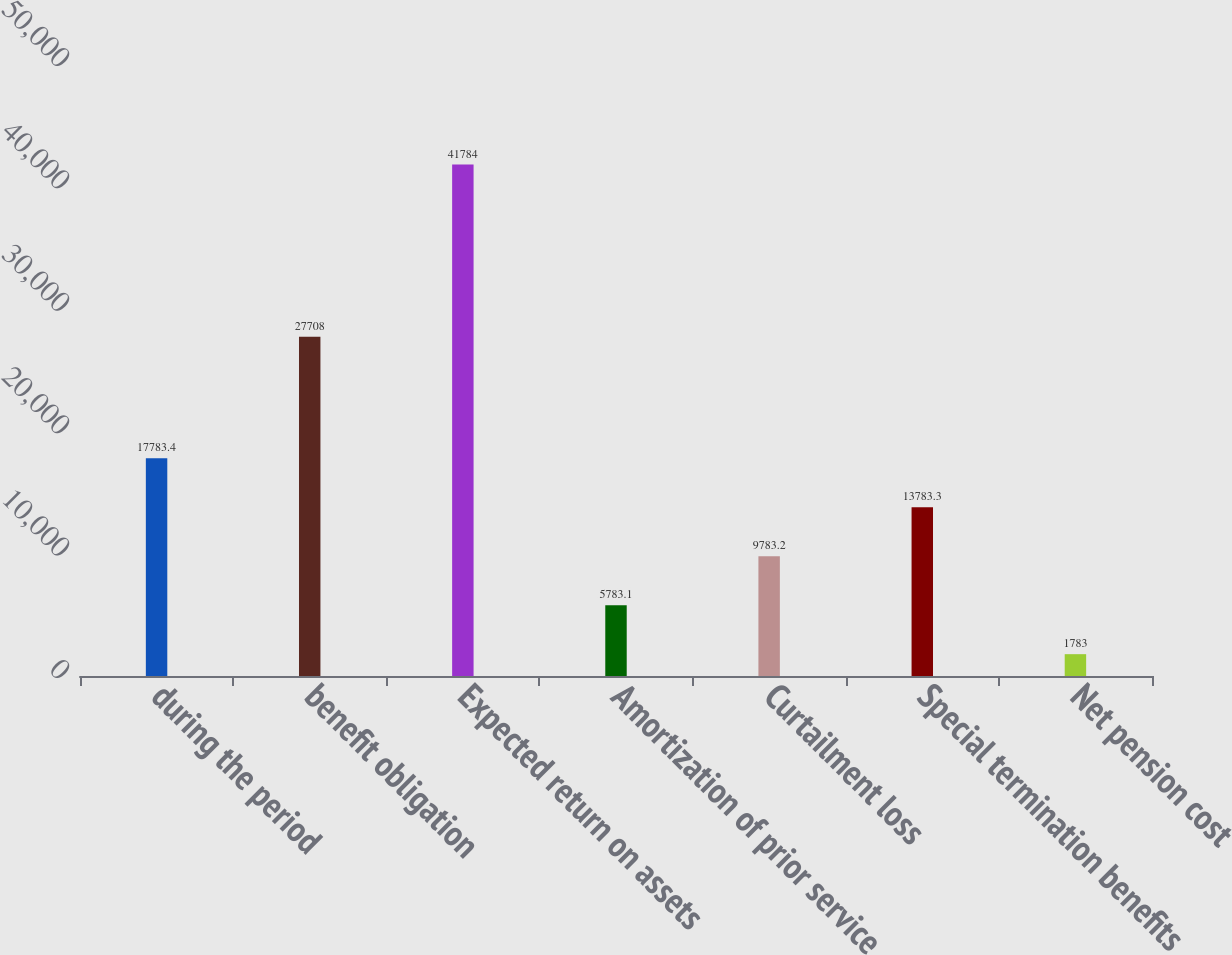Convert chart. <chart><loc_0><loc_0><loc_500><loc_500><bar_chart><fcel>during the period<fcel>benefit obligation<fcel>Expected return on assets<fcel>Amortization of prior service<fcel>Curtailment loss<fcel>Special termination benefits<fcel>Net pension cost<nl><fcel>17783.4<fcel>27708<fcel>41784<fcel>5783.1<fcel>9783.2<fcel>13783.3<fcel>1783<nl></chart> 